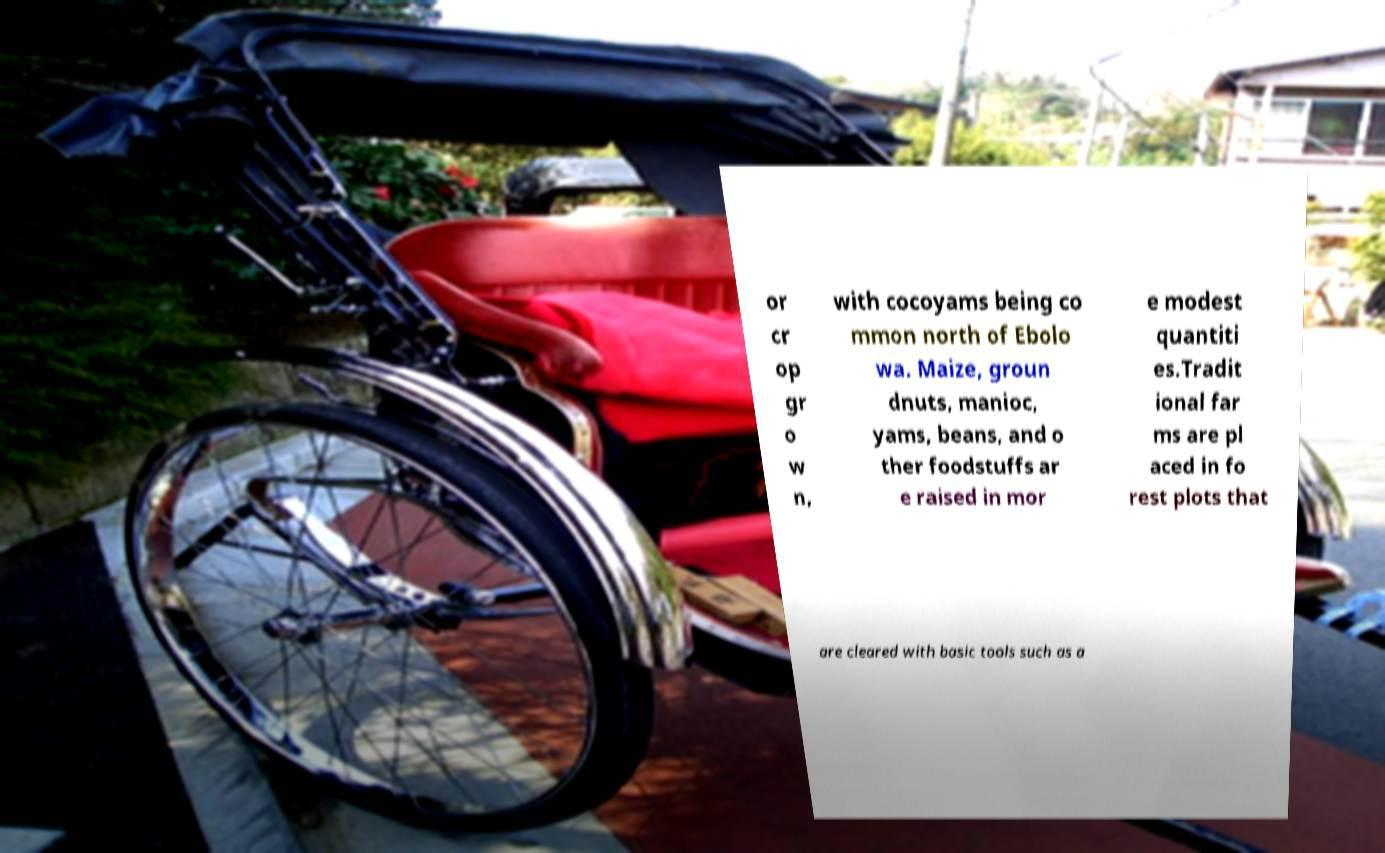Could you extract and type out the text from this image? or cr op gr o w n, with cocoyams being co mmon north of Ebolo wa. Maize, groun dnuts, manioc, yams, beans, and o ther foodstuffs ar e raised in mor e modest quantiti es.Tradit ional far ms are pl aced in fo rest plots that are cleared with basic tools such as a 